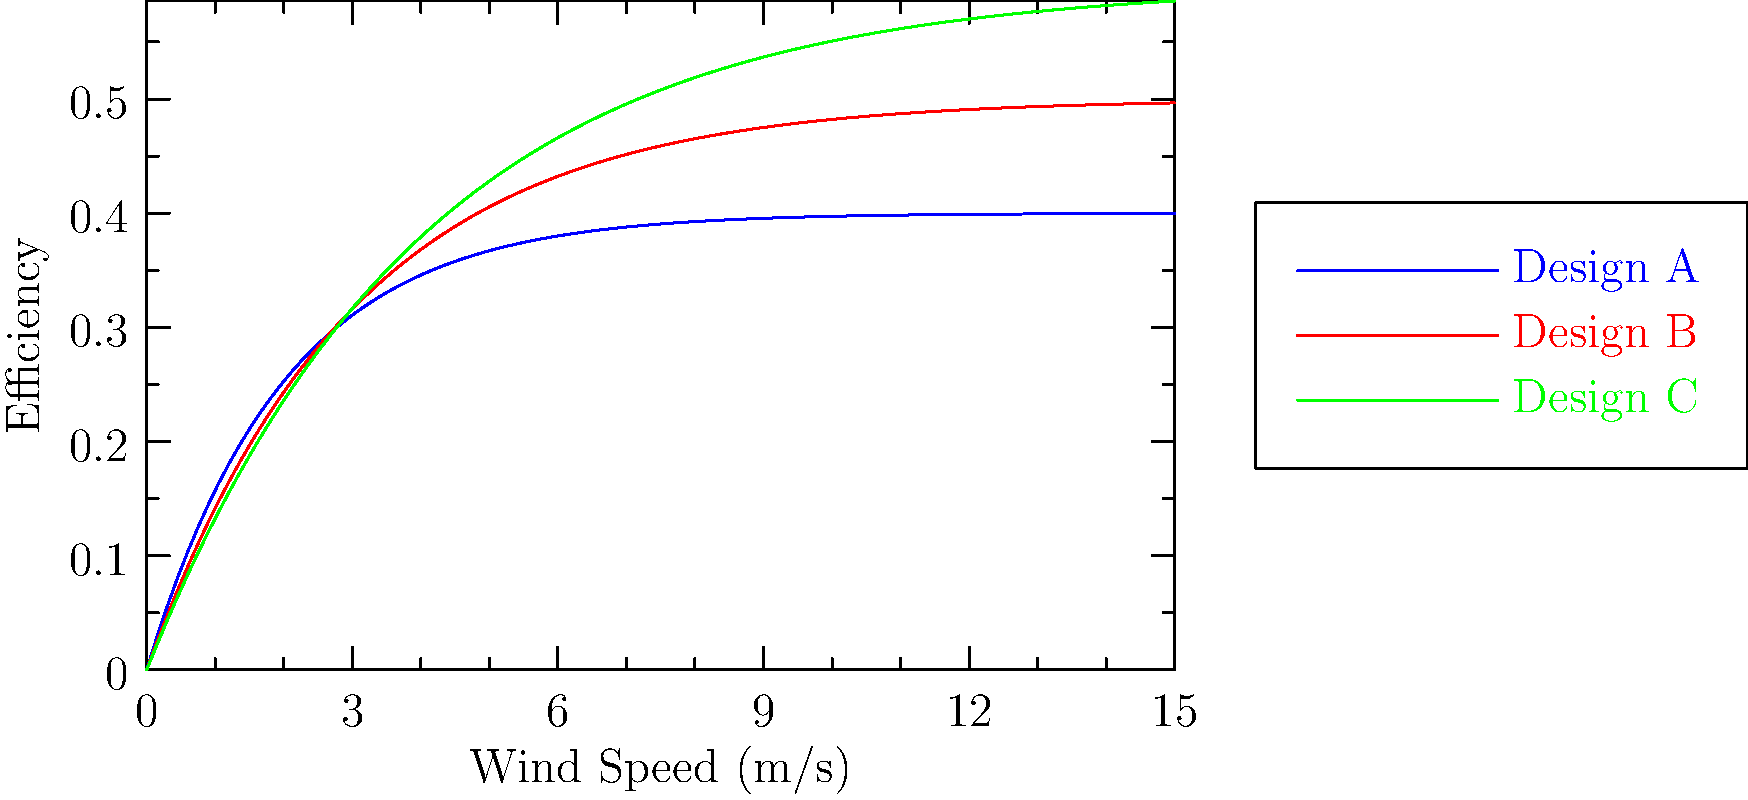The graph shows efficiency curves for three different wind turbine designs (A, B, and C) as a function of wind speed. Which design is likely to perform best in a location with consistently high wind speeds (>10 m/s)? To determine which design performs best at high wind speeds (>10 m/s), we need to analyze the efficiency curves:

1. Observe the behavior of each curve at wind speeds above 10 m/s:
   - Design A (blue): Reaches its maximum efficiency quickly and plateaus.
   - Design B (red): Gradually increases and plateaus at a higher efficiency than A.
   - Design C (green): Continues to increase, reaching the highest efficiency at high wind speeds.

2. Compare the efficiencies at wind speeds >10 m/s:
   - Design A: Approximately 0.4 (40%)
   - Design B: Approximately 0.5 (50%)
   - Design C: Approximately 0.6 (60%)

3. Analyze the trends:
   - Design C not only has the highest efficiency at high wind speeds but also shows potential for further improvement as wind speed increases.

4. Consider the practical implications:
   - In locations with consistently high wind speeds, Design C would capture more energy from the wind, resulting in higher power output and better overall performance.

Therefore, Design C is likely to perform best in a location with consistently high wind speeds (>10 m/s) due to its higher efficiency and continued improvement at high wind speeds.
Answer: Design C 